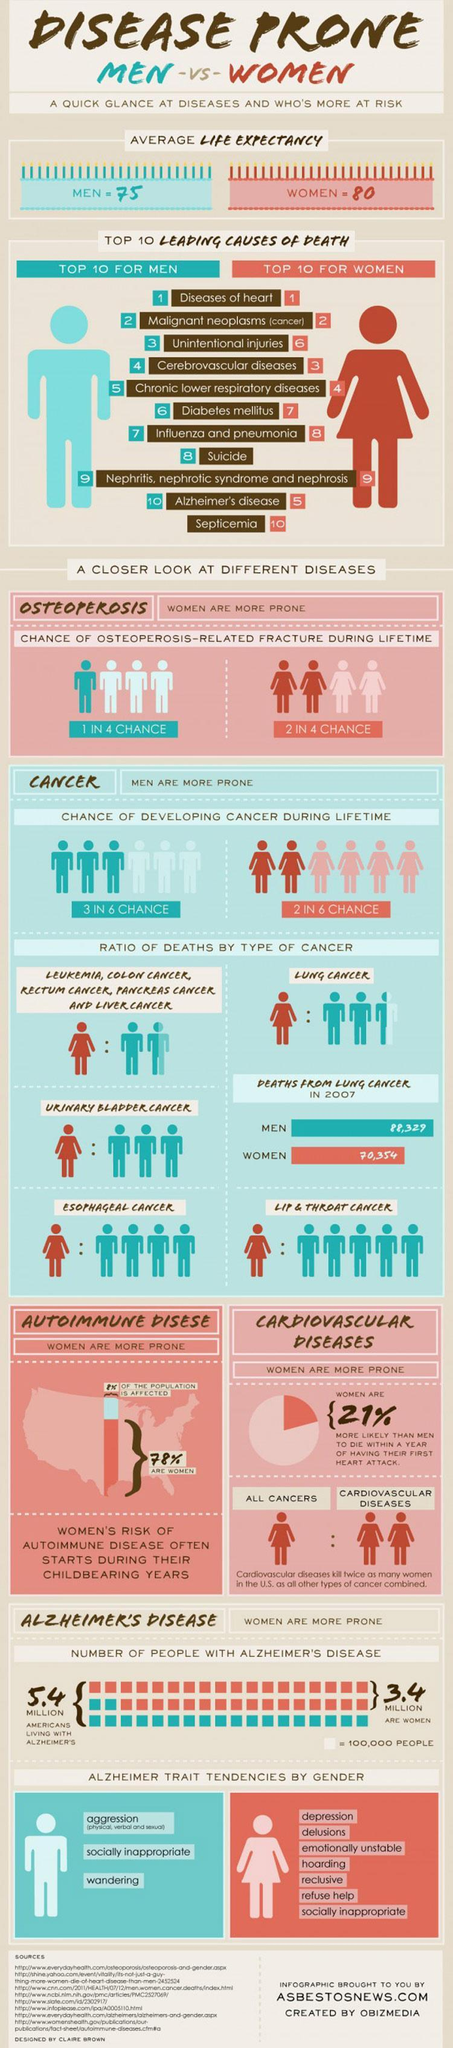Which disease rating are the same for both men and women when considering the top 10 leading causes of death
Answer the question with a short phrase. diseases of heart, malignant neoplasms (cancer), nephritis, nephrotic syndrome and nephrosis which is the leading cause of death that is found is women and not in men Septicemia What % of women have a chance of osteoperosis-related fracture during lifetime 50 How many years more is the life expectancy of women when compared to men 5 What % of men have a chance of osteoperosis-related fracture during lifetime 25 which is the leading cause of death that is found is men and not in women suicide what are the alzheimer trait tendencies in men agression, socially inappropriate, wandering who has higher life expectancy women 